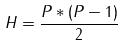Convert formula to latex. <formula><loc_0><loc_0><loc_500><loc_500>H = \frac { P * ( P - 1 ) } { 2 }</formula> 